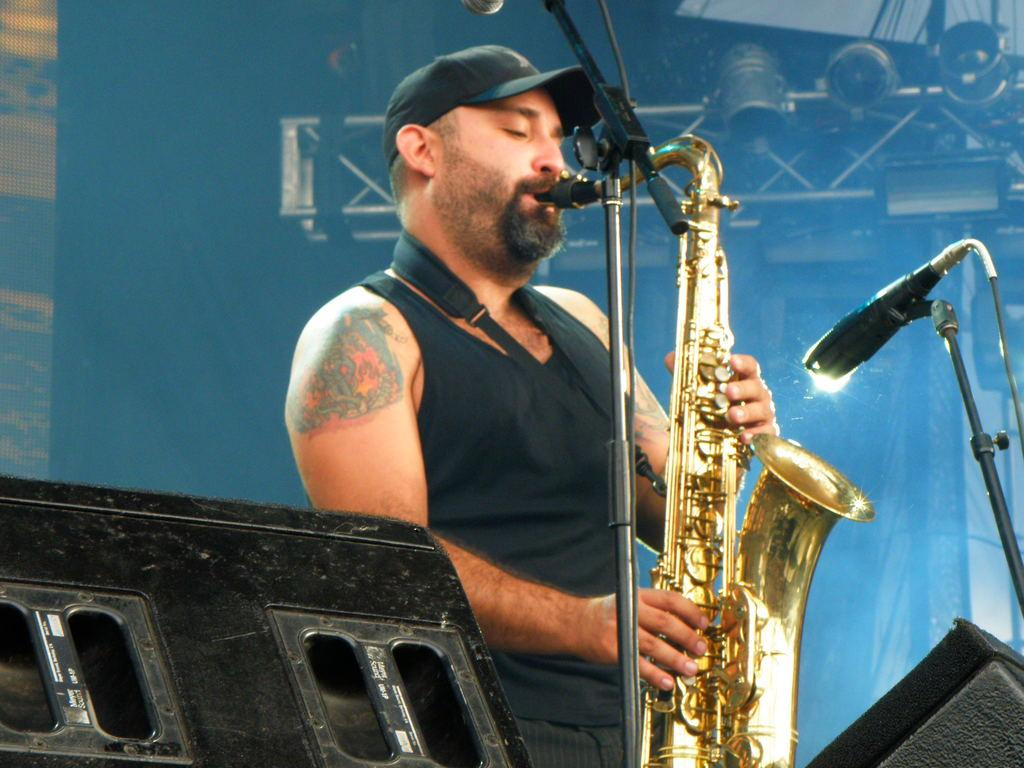What is the main subject of the image? There is a person in the image. What is the person holding in the image? The person is holding a musical instrument. What is the person standing near in the image? The person is standing in front of a microphone. What can be seen at the bottom of the image? There are objects at the bottom of the image. Can we determine if there is a wall behind the person? There may be a wall behind the person, but it is not clearly visible. What other object can be seen in the image? There is an iron stand visible in the image. What type of silver is being used as a caption in the image? There is no silver or caption present in the image. 